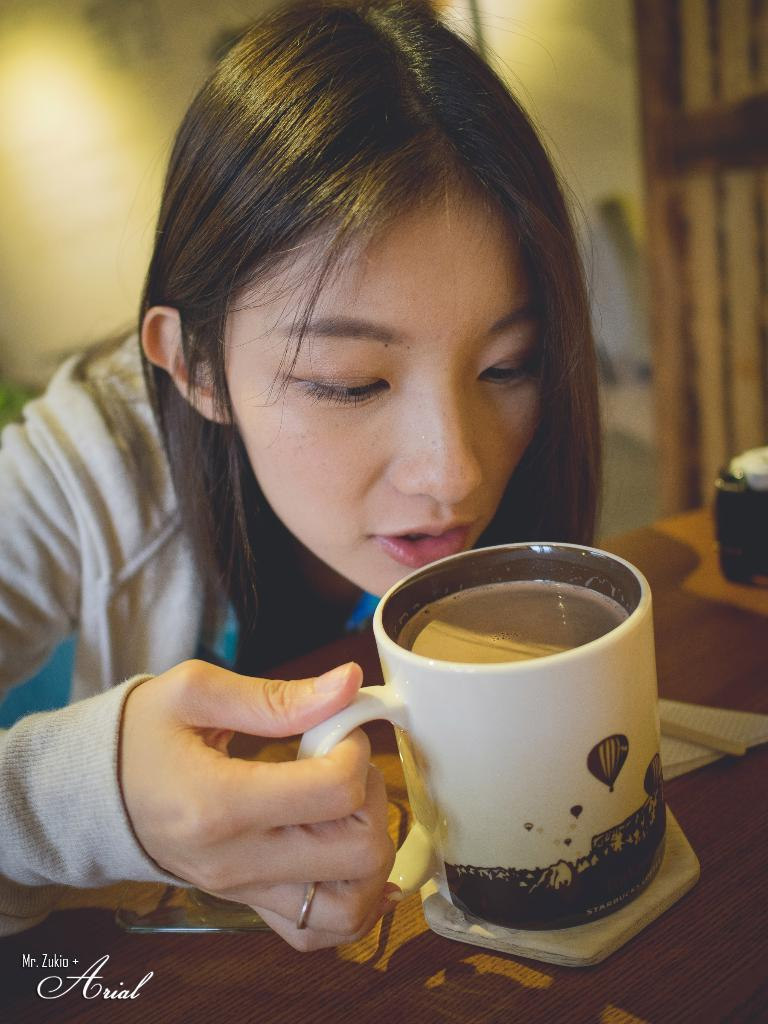Who is the main subject in the image? There is a girl in the image. What is the girl holding in her hand? The girl is holding a jug in her hand. What is the primary piece of furniture in the image? There is a table in the image. What can be seen in the image that provides illumination? Light is visible in the image. What type of structure is present in the background of the image? There is a wall in the image. What type of plant is growing on the user's receipt in the image? There is no plant or receipt present in the image. 